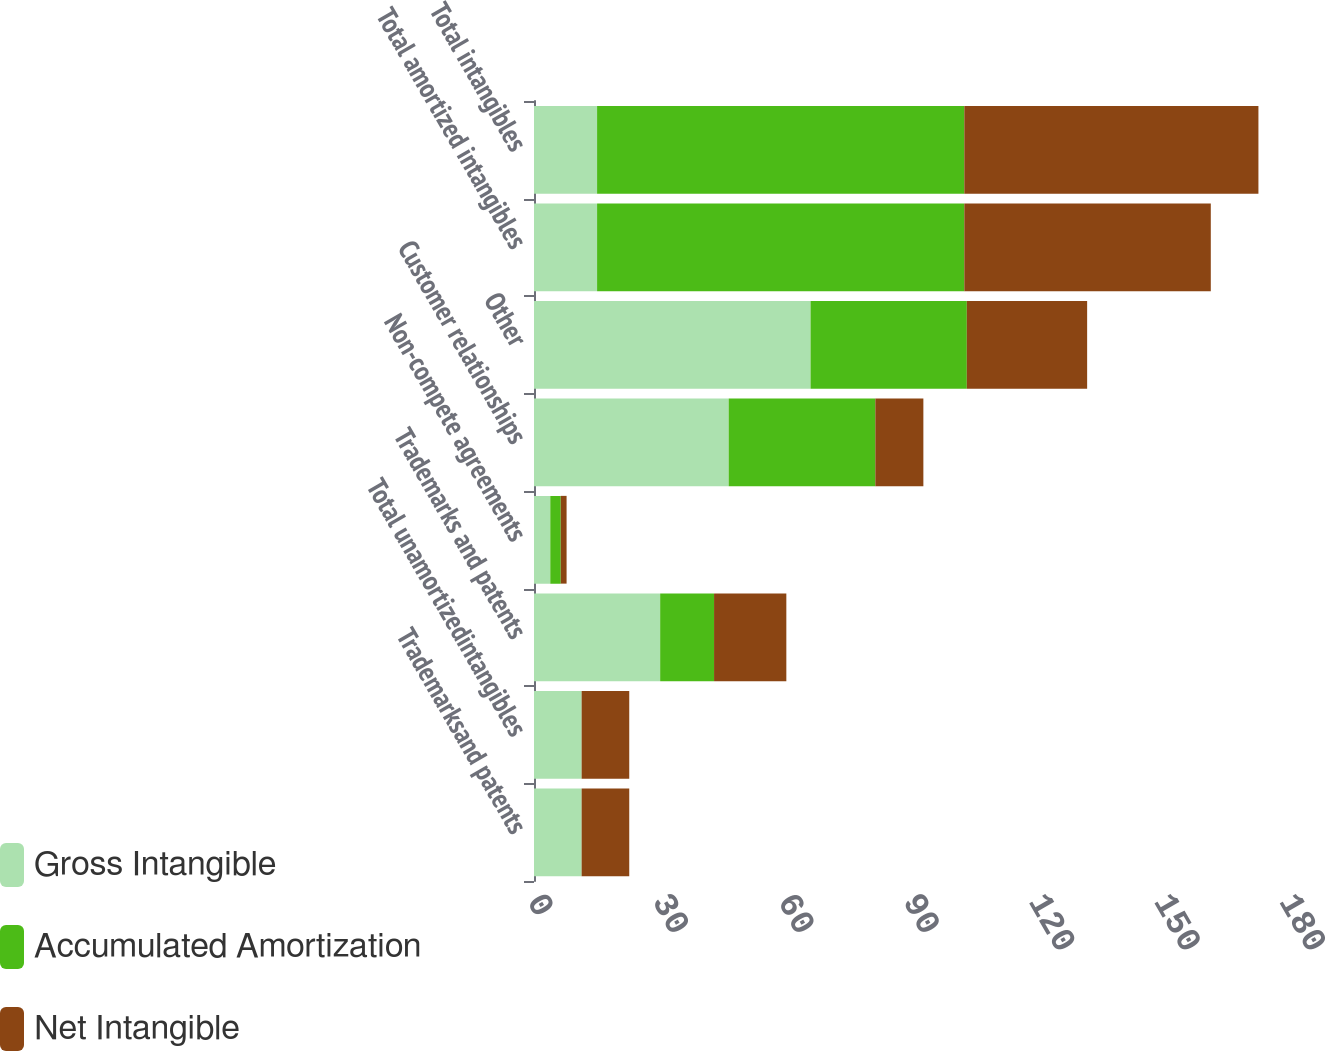<chart> <loc_0><loc_0><loc_500><loc_500><stacked_bar_chart><ecel><fcel>Trademarksand patents<fcel>Total unamortizedintangibles<fcel>Trademarks and patents<fcel>Non-compete agreements<fcel>Customer relationships<fcel>Other<fcel>Total amortized intangibles<fcel>Total intangibles<nl><fcel>Gross Intangible<fcel>11.4<fcel>11.4<fcel>30.2<fcel>3.9<fcel>46.6<fcel>66.2<fcel>15.1<fcel>15.1<nl><fcel>Accumulated Amortization<fcel>0<fcel>0<fcel>12.9<fcel>2.5<fcel>35.1<fcel>37.4<fcel>87.9<fcel>87.9<nl><fcel>Net Intangible<fcel>11.4<fcel>11.4<fcel>17.3<fcel>1.4<fcel>11.5<fcel>28.8<fcel>59<fcel>70.4<nl></chart> 